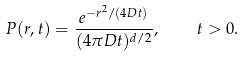<formula> <loc_0><loc_0><loc_500><loc_500>P ( { r } , t ) = \frac { e ^ { - r ^ { 2 } / ( 4 D t ) } } { ( 4 \pi D t ) ^ { d / 2 } } , \quad t > 0 .</formula> 